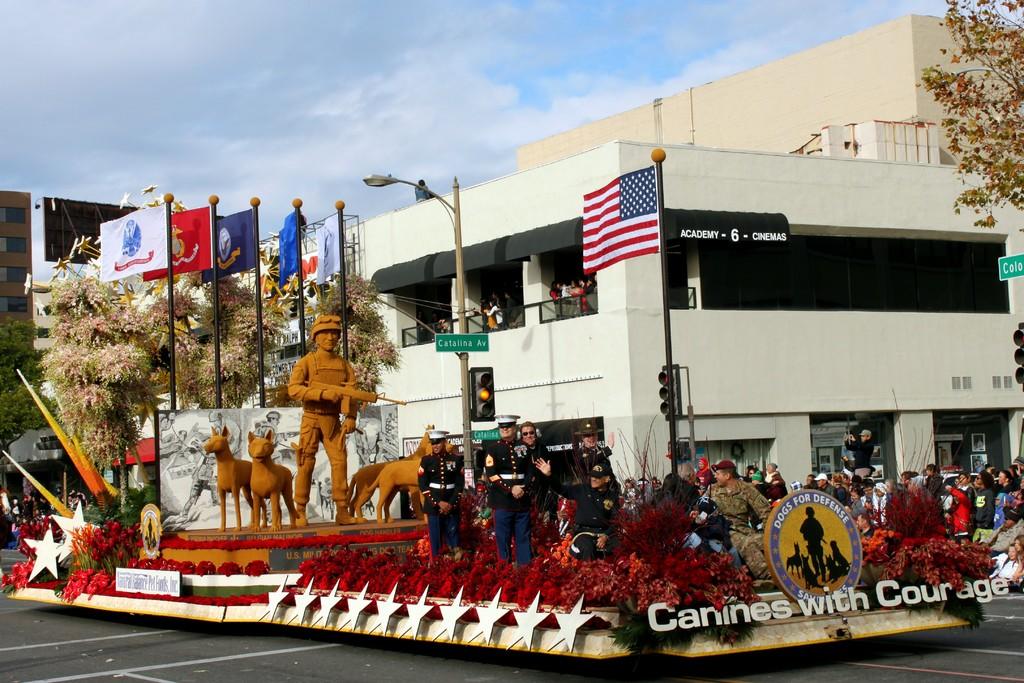What is this parade float in support of?
Make the answer very short. Canines with courage. Does this float represent canines?
Your answer should be very brief. Yes. 